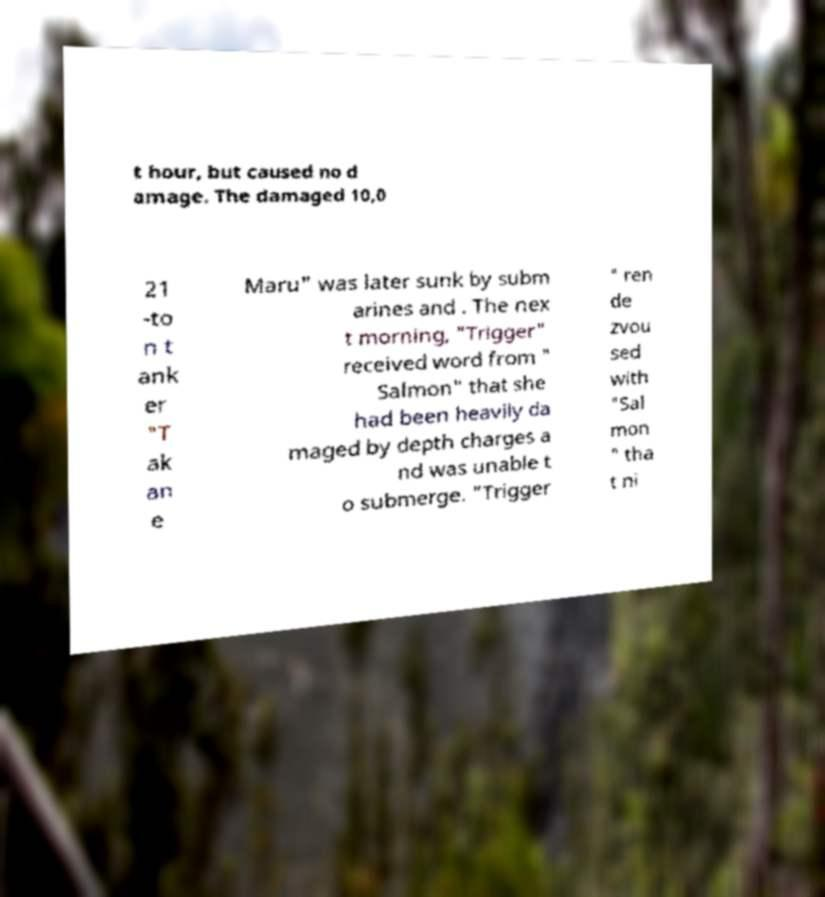Could you assist in decoding the text presented in this image and type it out clearly? t hour, but caused no d amage. The damaged 10,0 21 -to n t ank er "T ak an e Maru" was later sunk by subm arines and . The nex t morning, "Trigger" received word from " Salmon" that she had been heavily da maged by depth charges a nd was unable t o submerge. "Trigger " ren de zvou sed with "Sal mon " tha t ni 